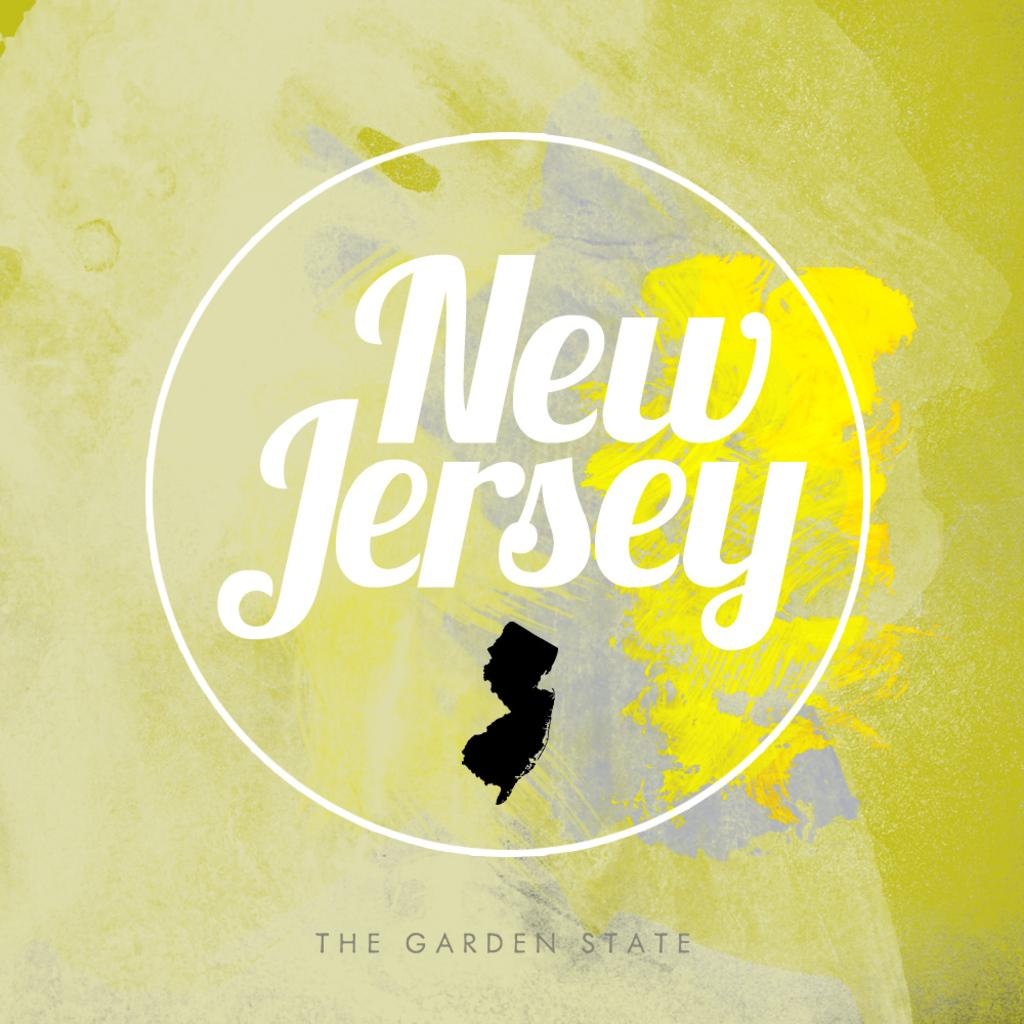<image>
Relay a brief, clear account of the picture shown. a map of New Jersey with the name of it above 